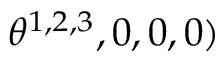Convert formula to latex. <formula><loc_0><loc_0><loc_500><loc_500>\theta ^ { 1 , 2 , 3 } , 0 , 0 , 0 )</formula> 